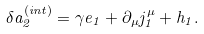Convert formula to latex. <formula><loc_0><loc_0><loc_500><loc_500>\delta a _ { 2 } ^ { \left ( i n t \right ) } = \gamma e _ { 1 } + \partial _ { \mu } j _ { 1 } ^ { \mu } + h _ { 1 } .</formula> 